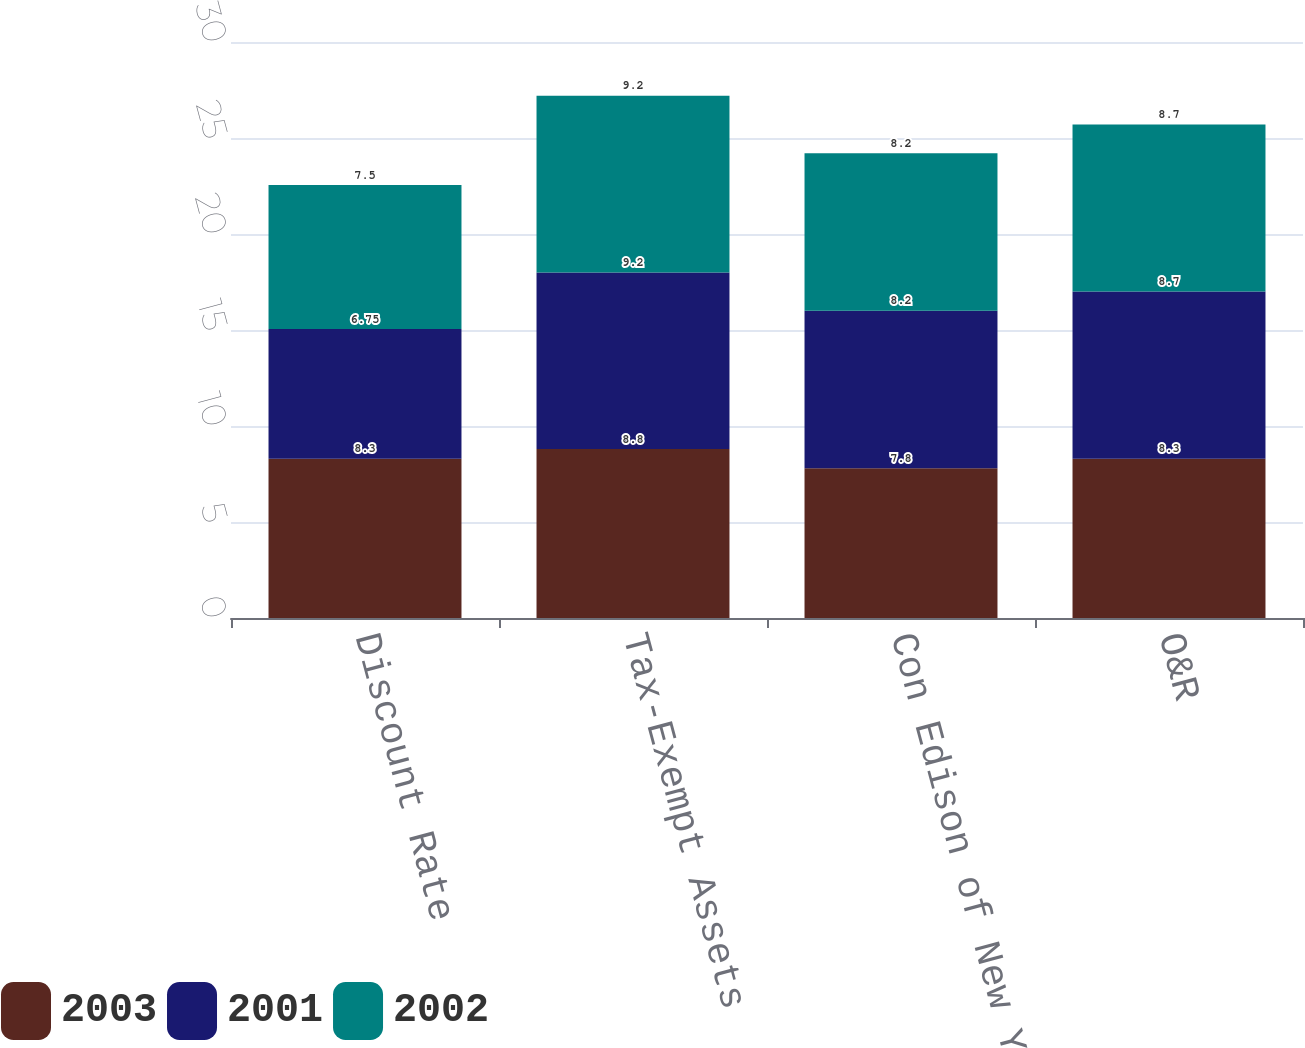Convert chart. <chart><loc_0><loc_0><loc_500><loc_500><stacked_bar_chart><ecel><fcel>Discount Rate<fcel>Tax-Exempt Assets<fcel>Con Edison of New York<fcel>O&R<nl><fcel>2003<fcel>8.3<fcel>8.8<fcel>7.8<fcel>8.3<nl><fcel>2001<fcel>6.75<fcel>9.2<fcel>8.2<fcel>8.7<nl><fcel>2002<fcel>7.5<fcel>9.2<fcel>8.2<fcel>8.7<nl></chart> 